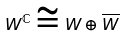Convert formula to latex. <formula><loc_0><loc_0><loc_500><loc_500>W ^ { \mathbb { C } } \cong W \oplus \overline { W }</formula> 